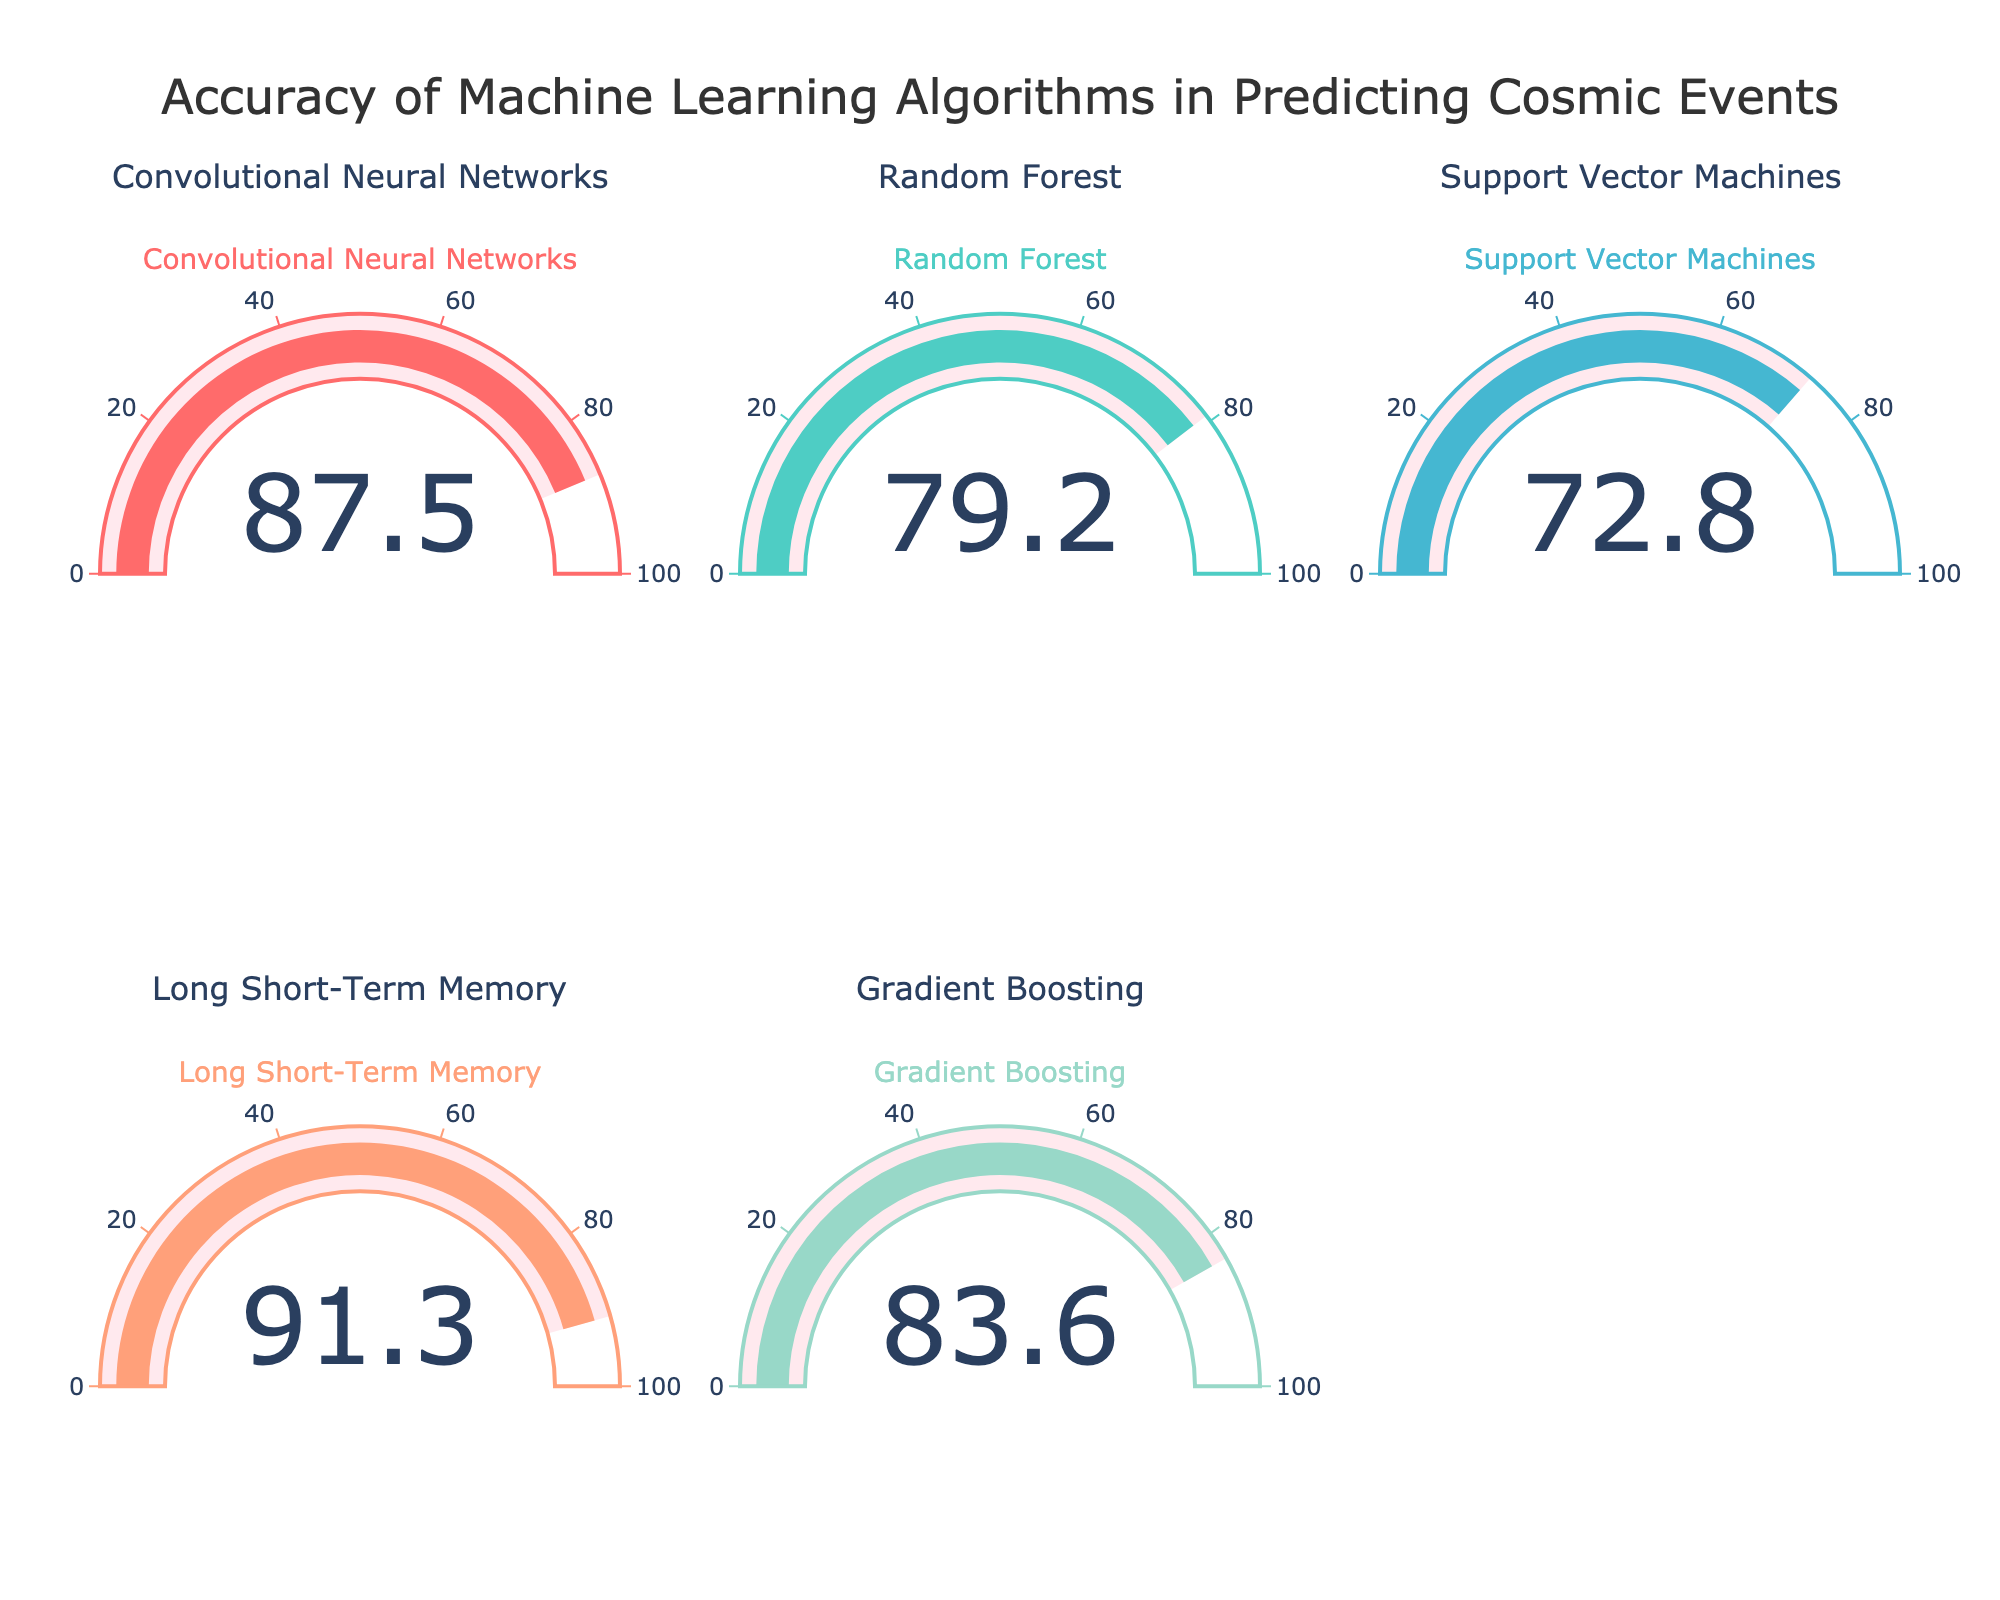What is the accuracy rate of the Long Short-Term Memory (LSTM) algorithm? The value displayed on the gauge for the Long Short-Term Memory algorithm shows its accuracy rate. The number on the gauge indicates 91.3%.
Answer: 91.3% Which algorithm has the lowest accuracy rate? By examining the values on each gauge, we can compare the accuracy rates. The Support Vector Machines algorithm has the gauge showing the lowest value at 72.8%.
Answer: Support Vector Machines What is the overall range of accuracy rates for the displayed machine learning algorithms? The range can be determined by finding the difference between the highest and lowest accuracy rates. The highest rate is 91.3% (LSTM) and the lowest is 72.8% (SVM). So, the range is 91.3% - 72.8% = 18.5%.
Answer: 18.5% How many algorithms have an accuracy rate above 80%? Examining each gauge, we see that Convolutional Neural Networks (87.5%), Long Short-Term Memory (91.3%), and Gradient Boosting (83.6%) all have accuracy rates above 80%. This totals to three algorithms.
Answer: 3 Which algorithm has a higher accuracy rate, Random Forest or Gradient Boosting? By comparing the values on the gauges, Random Forest shows 79.2% while Gradient Boosting shows 83.6%. Therefore, Gradient Boosting has a higher accuracy rate.
Answer: Gradient Boosting What is the average accuracy rate for the displayed algorithms? To find the average, we sum all the accuracy rates and divide by the number of algorithms: (87.5 + 79.2 + 72.8 + 91.3 + 83.6) / 5 = 414.4 / 5 = 82.88%.
Answer: 82.88% What is the difference in accuracy rate between the highest and second highest algorithms? The highest accuracy rate is 91.3% (LSTM) and the second highest is 87.5% (CNN). The difference is 91.3% - 87.5% = 3.8%.
Answer: 3.8% Which algorithm has the highest accuracy rate, and what is it? By identifying the highest value on the gauges, we see that the Long Short-Term Memory algorithm has the highest accuracy rate at 91.3%.
Answer: Long Short-Term Memory, 91.3% How does the average accuracy rate compare to the median accuracy rate of the algorithms? First, arrange the accuracy rates in ascending order: 72.8, 79.2, 83.6, 87.5, 91.3. The median is the middle value, 83.6. The average is 82.88% as calculated previously. Comparing them shows that the median (83.6%) is slightly higher than the average (82.88%).
Answer: Median is higher What is the accuracy percentage that has a difference of less than 5% with Convolutional Neural Networks? The accuracy rate for Convolutional Neural Networks is 87.5%. Checking other rates, Long Short-Term Memory (91.3%) and Gradient Boosting (83.6%) are within 5% difference: 87.5 - 83.6 = 3.9% and 91.3 - 87.5 = 3.8%.
Answer: Long Short-Term Memory, Gradient Boosting 